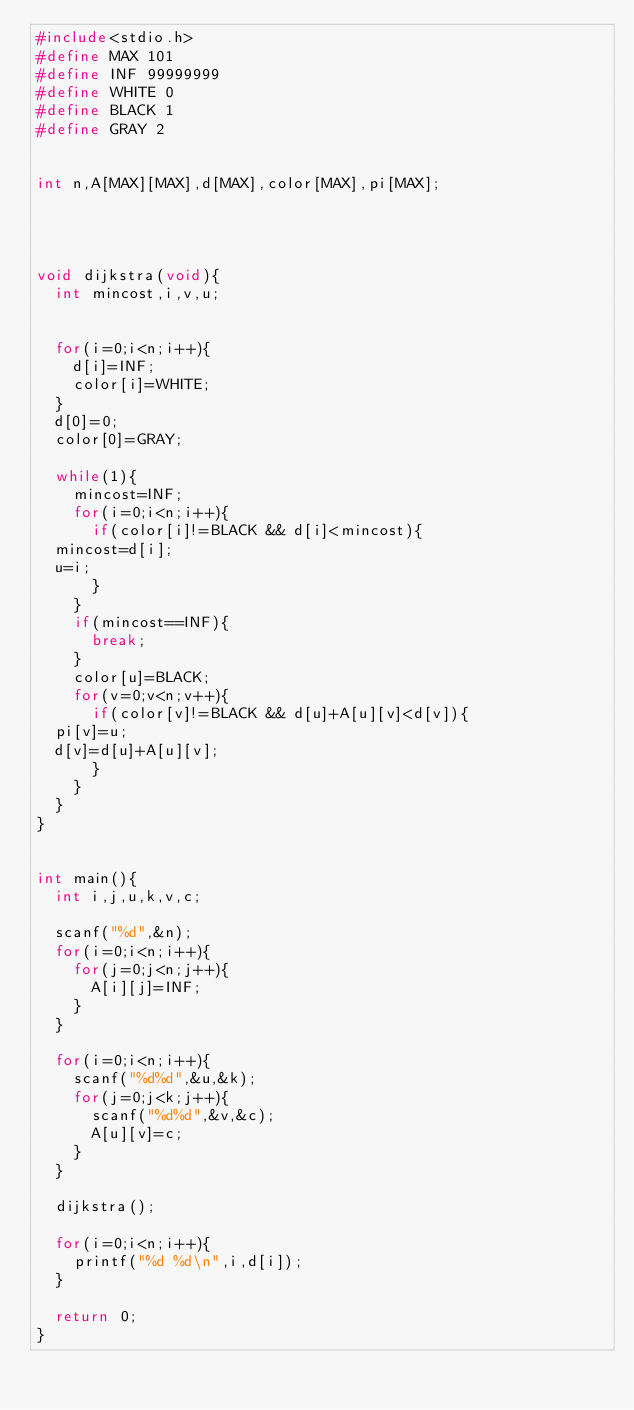<code> <loc_0><loc_0><loc_500><loc_500><_C_>#include<stdio.h>
#define MAX 101
#define INF 99999999
#define WHITE 0
#define BLACK 1
#define GRAY 2


int n,A[MAX][MAX],d[MAX],color[MAX],pi[MAX];




void dijkstra(void){
  int mincost,i,v,u;

  
  for(i=0;i<n;i++){
    d[i]=INF;
    color[i]=WHITE;
  }
  d[0]=0;
  color[0]=GRAY;

  while(1){
    mincost=INF;
    for(i=0;i<n;i++){
      if(color[i]!=BLACK && d[i]<mincost){
	mincost=d[i];
	u=i;
      }
    }
    if(mincost==INF){
      break;
    }
    color[u]=BLACK;
    for(v=0;v<n;v++){
      if(color[v]!=BLACK && d[u]+A[u][v]<d[v]){
	pi[v]=u;
	d[v]=d[u]+A[u][v];
      }
    }
  }
}


int main(){
  int i,j,u,k,v,c;

  scanf("%d",&n);
  for(i=0;i<n;i++){
    for(j=0;j<n;j++){
      A[i][j]=INF;
    }
  }
  
  for(i=0;i<n;i++){
    scanf("%d%d",&u,&k);
    for(j=0;j<k;j++){
      scanf("%d%d",&v,&c);
      A[u][v]=c;
    }
  }

  dijkstra();

  for(i=0;i<n;i++){
    printf("%d %d\n",i,d[i]);
  }
  
  return 0;
}


  

</code> 